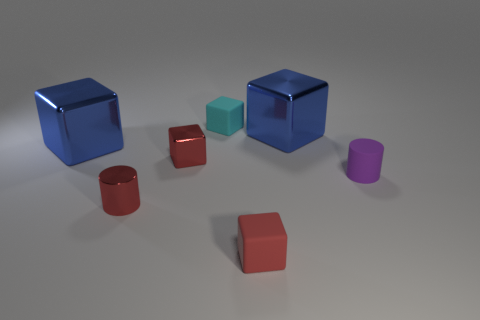Are there any other things that have the same shape as the cyan object?
Your response must be concise. Yes. What number of blue blocks are in front of the purple thing?
Make the answer very short. 0. Are there the same number of red objects that are in front of the purple object and tiny cylinders?
Provide a succinct answer. Yes. Do the purple thing and the cyan object have the same material?
Provide a short and direct response. Yes. There is a matte object that is behind the small red cylinder and on the right side of the small cyan rubber object; how big is it?
Make the answer very short. Small. How many blue shiny cubes have the same size as the cyan rubber block?
Give a very brief answer. 0. There is a red cube behind the cylinder left of the tiny cyan thing; what is its size?
Your response must be concise. Small. Does the blue shiny thing on the left side of the small metallic cylinder have the same shape as the blue thing right of the tiny cyan thing?
Ensure brevity in your answer.  Yes. There is a tiny object that is behind the small metallic cylinder and on the right side of the cyan object; what is its color?
Keep it short and to the point. Purple. Are there any tiny rubber spheres of the same color as the small matte cylinder?
Your answer should be very brief. No. 